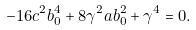<formula> <loc_0><loc_0><loc_500><loc_500>- 1 6 c ^ { 2 } b _ { 0 } ^ { 4 } + 8 \gamma ^ { 2 } a b _ { 0 } ^ { 2 } + \gamma ^ { 4 } = 0 .</formula> 